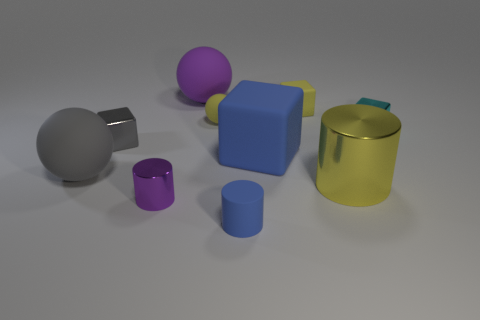Subtract all yellow matte spheres. How many spheres are left? 2 Subtract all cylinders. How many objects are left? 7 Subtract 4 cubes. How many cubes are left? 0 Subtract all gray balls. How many balls are left? 2 Add 10 big brown cylinders. How many big brown cylinders exist? 10 Subtract 0 blue balls. How many objects are left? 10 Subtract all red cylinders. Subtract all red balls. How many cylinders are left? 3 Subtract all small matte things. Subtract all yellow blocks. How many objects are left? 6 Add 3 big matte things. How many big matte things are left? 6 